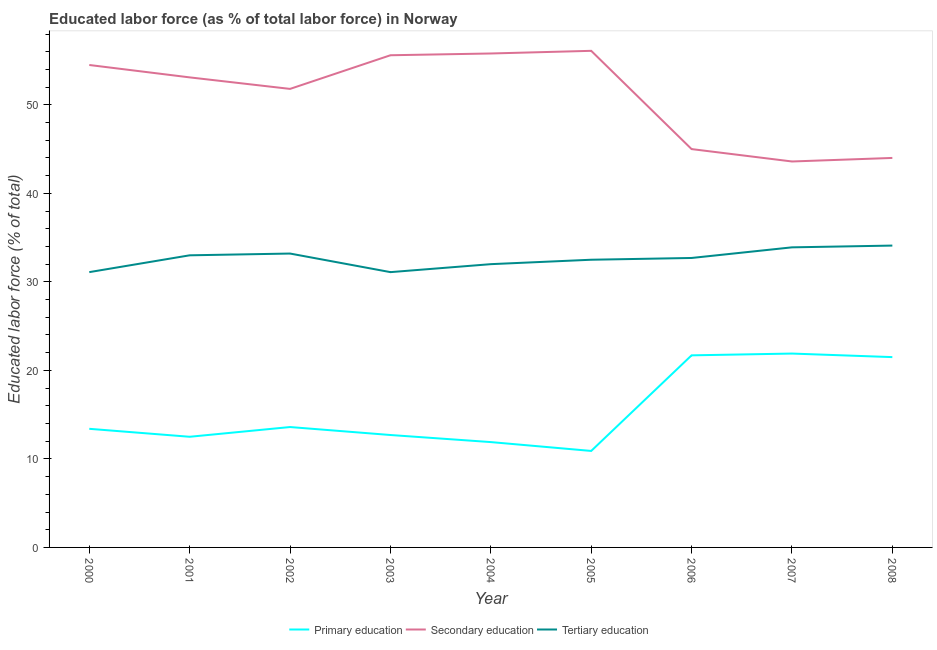Does the line corresponding to percentage of labor force who received tertiary education intersect with the line corresponding to percentage of labor force who received primary education?
Your answer should be compact. No. Is the number of lines equal to the number of legend labels?
Offer a terse response. Yes. What is the percentage of labor force who received tertiary education in 2006?
Your answer should be very brief. 32.7. Across all years, what is the maximum percentage of labor force who received tertiary education?
Offer a very short reply. 34.1. Across all years, what is the minimum percentage of labor force who received tertiary education?
Give a very brief answer. 31.1. What is the total percentage of labor force who received primary education in the graph?
Provide a short and direct response. 140.1. What is the difference between the percentage of labor force who received primary education in 2007 and the percentage of labor force who received secondary education in 2005?
Your answer should be compact. -34.2. What is the average percentage of labor force who received secondary education per year?
Offer a terse response. 51.06. In the year 2005, what is the difference between the percentage of labor force who received secondary education and percentage of labor force who received primary education?
Ensure brevity in your answer.  45.2. In how many years, is the percentage of labor force who received secondary education greater than 12 %?
Keep it short and to the point. 9. What is the ratio of the percentage of labor force who received secondary education in 2002 to that in 2007?
Your answer should be compact. 1.19. Is the percentage of labor force who received secondary education in 2000 less than that in 2004?
Ensure brevity in your answer.  Yes. Is the difference between the percentage of labor force who received tertiary education in 2003 and 2007 greater than the difference between the percentage of labor force who received secondary education in 2003 and 2007?
Give a very brief answer. No. What is the difference between the highest and the second highest percentage of labor force who received tertiary education?
Offer a terse response. 0.2. What is the difference between the highest and the lowest percentage of labor force who received secondary education?
Your answer should be very brief. 12.5. In how many years, is the percentage of labor force who received tertiary education greater than the average percentage of labor force who received tertiary education taken over all years?
Ensure brevity in your answer.  5. Is the sum of the percentage of labor force who received tertiary education in 2002 and 2003 greater than the maximum percentage of labor force who received primary education across all years?
Offer a terse response. Yes. Is it the case that in every year, the sum of the percentage of labor force who received primary education and percentage of labor force who received secondary education is greater than the percentage of labor force who received tertiary education?
Keep it short and to the point. Yes. Is the percentage of labor force who received tertiary education strictly greater than the percentage of labor force who received secondary education over the years?
Provide a succinct answer. No. Is the percentage of labor force who received secondary education strictly less than the percentage of labor force who received primary education over the years?
Provide a short and direct response. No. How many lines are there?
Ensure brevity in your answer.  3. What is the difference between two consecutive major ticks on the Y-axis?
Your answer should be compact. 10. Are the values on the major ticks of Y-axis written in scientific E-notation?
Offer a very short reply. No. Does the graph contain any zero values?
Keep it short and to the point. No. Where does the legend appear in the graph?
Keep it short and to the point. Bottom center. What is the title of the graph?
Make the answer very short. Educated labor force (as % of total labor force) in Norway. Does "Domestic" appear as one of the legend labels in the graph?
Offer a very short reply. No. What is the label or title of the Y-axis?
Keep it short and to the point. Educated labor force (% of total). What is the Educated labor force (% of total) of Primary education in 2000?
Offer a terse response. 13.4. What is the Educated labor force (% of total) of Secondary education in 2000?
Your answer should be very brief. 54.5. What is the Educated labor force (% of total) of Tertiary education in 2000?
Make the answer very short. 31.1. What is the Educated labor force (% of total) in Primary education in 2001?
Your response must be concise. 12.5. What is the Educated labor force (% of total) in Secondary education in 2001?
Your answer should be very brief. 53.1. What is the Educated labor force (% of total) in Tertiary education in 2001?
Offer a terse response. 33. What is the Educated labor force (% of total) of Primary education in 2002?
Your answer should be very brief. 13.6. What is the Educated labor force (% of total) of Secondary education in 2002?
Give a very brief answer. 51.8. What is the Educated labor force (% of total) of Tertiary education in 2002?
Your response must be concise. 33.2. What is the Educated labor force (% of total) of Primary education in 2003?
Keep it short and to the point. 12.7. What is the Educated labor force (% of total) of Secondary education in 2003?
Ensure brevity in your answer.  55.6. What is the Educated labor force (% of total) of Tertiary education in 2003?
Make the answer very short. 31.1. What is the Educated labor force (% of total) in Primary education in 2004?
Give a very brief answer. 11.9. What is the Educated labor force (% of total) in Secondary education in 2004?
Give a very brief answer. 55.8. What is the Educated labor force (% of total) in Primary education in 2005?
Give a very brief answer. 10.9. What is the Educated labor force (% of total) in Secondary education in 2005?
Ensure brevity in your answer.  56.1. What is the Educated labor force (% of total) of Tertiary education in 2005?
Keep it short and to the point. 32.5. What is the Educated labor force (% of total) in Primary education in 2006?
Your response must be concise. 21.7. What is the Educated labor force (% of total) in Tertiary education in 2006?
Ensure brevity in your answer.  32.7. What is the Educated labor force (% of total) in Primary education in 2007?
Ensure brevity in your answer.  21.9. What is the Educated labor force (% of total) of Secondary education in 2007?
Your answer should be compact. 43.6. What is the Educated labor force (% of total) in Tertiary education in 2007?
Your answer should be very brief. 33.9. What is the Educated labor force (% of total) in Secondary education in 2008?
Offer a terse response. 44. What is the Educated labor force (% of total) in Tertiary education in 2008?
Keep it short and to the point. 34.1. Across all years, what is the maximum Educated labor force (% of total) in Primary education?
Offer a terse response. 21.9. Across all years, what is the maximum Educated labor force (% of total) in Secondary education?
Offer a very short reply. 56.1. Across all years, what is the maximum Educated labor force (% of total) of Tertiary education?
Your response must be concise. 34.1. Across all years, what is the minimum Educated labor force (% of total) of Primary education?
Keep it short and to the point. 10.9. Across all years, what is the minimum Educated labor force (% of total) of Secondary education?
Provide a succinct answer. 43.6. Across all years, what is the minimum Educated labor force (% of total) of Tertiary education?
Your answer should be very brief. 31.1. What is the total Educated labor force (% of total) in Primary education in the graph?
Your answer should be very brief. 140.1. What is the total Educated labor force (% of total) in Secondary education in the graph?
Offer a terse response. 459.5. What is the total Educated labor force (% of total) in Tertiary education in the graph?
Offer a terse response. 293.6. What is the difference between the Educated labor force (% of total) in Primary education in 2000 and that in 2001?
Provide a succinct answer. 0.9. What is the difference between the Educated labor force (% of total) of Tertiary education in 2000 and that in 2001?
Your response must be concise. -1.9. What is the difference between the Educated labor force (% of total) of Secondary education in 2000 and that in 2002?
Provide a succinct answer. 2.7. What is the difference between the Educated labor force (% of total) of Tertiary education in 2000 and that in 2002?
Your response must be concise. -2.1. What is the difference between the Educated labor force (% of total) in Secondary education in 2000 and that in 2003?
Provide a short and direct response. -1.1. What is the difference between the Educated labor force (% of total) in Tertiary education in 2000 and that in 2003?
Your response must be concise. 0. What is the difference between the Educated labor force (% of total) of Primary education in 2000 and that in 2005?
Provide a short and direct response. 2.5. What is the difference between the Educated labor force (% of total) of Secondary education in 2000 and that in 2005?
Offer a terse response. -1.6. What is the difference between the Educated labor force (% of total) of Secondary education in 2000 and that in 2006?
Ensure brevity in your answer.  9.5. What is the difference between the Educated labor force (% of total) in Tertiary education in 2000 and that in 2006?
Provide a succinct answer. -1.6. What is the difference between the Educated labor force (% of total) of Secondary education in 2000 and that in 2008?
Make the answer very short. 10.5. What is the difference between the Educated labor force (% of total) of Tertiary education in 2000 and that in 2008?
Offer a very short reply. -3. What is the difference between the Educated labor force (% of total) in Secondary education in 2001 and that in 2002?
Ensure brevity in your answer.  1.3. What is the difference between the Educated labor force (% of total) of Tertiary education in 2001 and that in 2003?
Your answer should be compact. 1.9. What is the difference between the Educated labor force (% of total) of Primary education in 2001 and that in 2004?
Provide a short and direct response. 0.6. What is the difference between the Educated labor force (% of total) of Tertiary education in 2001 and that in 2004?
Give a very brief answer. 1. What is the difference between the Educated labor force (% of total) in Primary education in 2001 and that in 2005?
Your response must be concise. 1.6. What is the difference between the Educated labor force (% of total) of Secondary education in 2001 and that in 2005?
Provide a succinct answer. -3. What is the difference between the Educated labor force (% of total) of Tertiary education in 2001 and that in 2005?
Offer a terse response. 0.5. What is the difference between the Educated labor force (% of total) in Primary education in 2001 and that in 2006?
Your response must be concise. -9.2. What is the difference between the Educated labor force (% of total) of Secondary education in 2001 and that in 2007?
Offer a very short reply. 9.5. What is the difference between the Educated labor force (% of total) in Tertiary education in 2001 and that in 2008?
Your answer should be very brief. -1.1. What is the difference between the Educated labor force (% of total) of Primary education in 2002 and that in 2003?
Keep it short and to the point. 0.9. What is the difference between the Educated labor force (% of total) of Secondary education in 2002 and that in 2003?
Provide a short and direct response. -3.8. What is the difference between the Educated labor force (% of total) of Tertiary education in 2002 and that in 2003?
Ensure brevity in your answer.  2.1. What is the difference between the Educated labor force (% of total) in Primary education in 2002 and that in 2004?
Your answer should be compact. 1.7. What is the difference between the Educated labor force (% of total) of Tertiary education in 2002 and that in 2004?
Your response must be concise. 1.2. What is the difference between the Educated labor force (% of total) of Primary education in 2002 and that in 2005?
Give a very brief answer. 2.7. What is the difference between the Educated labor force (% of total) of Secondary education in 2002 and that in 2005?
Your answer should be very brief. -4.3. What is the difference between the Educated labor force (% of total) of Tertiary education in 2002 and that in 2005?
Your response must be concise. 0.7. What is the difference between the Educated labor force (% of total) of Primary education in 2002 and that in 2007?
Your answer should be very brief. -8.3. What is the difference between the Educated labor force (% of total) in Secondary education in 2002 and that in 2007?
Ensure brevity in your answer.  8.2. What is the difference between the Educated labor force (% of total) of Tertiary education in 2002 and that in 2007?
Give a very brief answer. -0.7. What is the difference between the Educated labor force (% of total) in Primary education in 2002 and that in 2008?
Your response must be concise. -7.9. What is the difference between the Educated labor force (% of total) in Secondary education in 2002 and that in 2008?
Offer a very short reply. 7.8. What is the difference between the Educated labor force (% of total) in Tertiary education in 2002 and that in 2008?
Give a very brief answer. -0.9. What is the difference between the Educated labor force (% of total) in Primary education in 2003 and that in 2004?
Give a very brief answer. 0.8. What is the difference between the Educated labor force (% of total) of Tertiary education in 2003 and that in 2004?
Offer a terse response. -0.9. What is the difference between the Educated labor force (% of total) of Primary education in 2003 and that in 2005?
Provide a succinct answer. 1.8. What is the difference between the Educated labor force (% of total) of Tertiary education in 2003 and that in 2005?
Your answer should be compact. -1.4. What is the difference between the Educated labor force (% of total) of Tertiary education in 2003 and that in 2006?
Keep it short and to the point. -1.6. What is the difference between the Educated labor force (% of total) in Primary education in 2003 and that in 2007?
Keep it short and to the point. -9.2. What is the difference between the Educated labor force (% of total) in Secondary education in 2003 and that in 2007?
Make the answer very short. 12. What is the difference between the Educated labor force (% of total) of Primary education in 2003 and that in 2008?
Ensure brevity in your answer.  -8.8. What is the difference between the Educated labor force (% of total) of Secondary education in 2003 and that in 2008?
Your answer should be compact. 11.6. What is the difference between the Educated labor force (% of total) of Secondary education in 2004 and that in 2005?
Your answer should be compact. -0.3. What is the difference between the Educated labor force (% of total) of Secondary education in 2004 and that in 2006?
Keep it short and to the point. 10.8. What is the difference between the Educated labor force (% of total) of Primary education in 2004 and that in 2007?
Provide a succinct answer. -10. What is the difference between the Educated labor force (% of total) in Tertiary education in 2005 and that in 2006?
Your response must be concise. -0.2. What is the difference between the Educated labor force (% of total) of Secondary education in 2005 and that in 2007?
Your response must be concise. 12.5. What is the difference between the Educated labor force (% of total) in Tertiary education in 2005 and that in 2008?
Your answer should be very brief. -1.6. What is the difference between the Educated labor force (% of total) in Primary education in 2006 and that in 2007?
Your answer should be very brief. -0.2. What is the difference between the Educated labor force (% of total) of Tertiary education in 2006 and that in 2007?
Your answer should be very brief. -1.2. What is the difference between the Educated labor force (% of total) in Primary education in 2007 and that in 2008?
Offer a terse response. 0.4. What is the difference between the Educated labor force (% of total) in Secondary education in 2007 and that in 2008?
Your response must be concise. -0.4. What is the difference between the Educated labor force (% of total) in Primary education in 2000 and the Educated labor force (% of total) in Secondary education in 2001?
Offer a very short reply. -39.7. What is the difference between the Educated labor force (% of total) in Primary education in 2000 and the Educated labor force (% of total) in Tertiary education in 2001?
Your answer should be compact. -19.6. What is the difference between the Educated labor force (% of total) of Secondary education in 2000 and the Educated labor force (% of total) of Tertiary education in 2001?
Provide a succinct answer. 21.5. What is the difference between the Educated labor force (% of total) in Primary education in 2000 and the Educated labor force (% of total) in Secondary education in 2002?
Make the answer very short. -38.4. What is the difference between the Educated labor force (% of total) in Primary education in 2000 and the Educated labor force (% of total) in Tertiary education in 2002?
Offer a very short reply. -19.8. What is the difference between the Educated labor force (% of total) of Secondary education in 2000 and the Educated labor force (% of total) of Tertiary education in 2002?
Provide a succinct answer. 21.3. What is the difference between the Educated labor force (% of total) of Primary education in 2000 and the Educated labor force (% of total) of Secondary education in 2003?
Your answer should be compact. -42.2. What is the difference between the Educated labor force (% of total) in Primary education in 2000 and the Educated labor force (% of total) in Tertiary education in 2003?
Ensure brevity in your answer.  -17.7. What is the difference between the Educated labor force (% of total) of Secondary education in 2000 and the Educated labor force (% of total) of Tertiary education in 2003?
Offer a terse response. 23.4. What is the difference between the Educated labor force (% of total) of Primary education in 2000 and the Educated labor force (% of total) of Secondary education in 2004?
Provide a short and direct response. -42.4. What is the difference between the Educated labor force (% of total) of Primary education in 2000 and the Educated labor force (% of total) of Tertiary education in 2004?
Ensure brevity in your answer.  -18.6. What is the difference between the Educated labor force (% of total) in Primary education in 2000 and the Educated labor force (% of total) in Secondary education in 2005?
Give a very brief answer. -42.7. What is the difference between the Educated labor force (% of total) of Primary education in 2000 and the Educated labor force (% of total) of Tertiary education in 2005?
Ensure brevity in your answer.  -19.1. What is the difference between the Educated labor force (% of total) in Primary education in 2000 and the Educated labor force (% of total) in Secondary education in 2006?
Offer a very short reply. -31.6. What is the difference between the Educated labor force (% of total) of Primary education in 2000 and the Educated labor force (% of total) of Tertiary education in 2006?
Your response must be concise. -19.3. What is the difference between the Educated labor force (% of total) in Secondary education in 2000 and the Educated labor force (% of total) in Tertiary education in 2006?
Ensure brevity in your answer.  21.8. What is the difference between the Educated labor force (% of total) in Primary education in 2000 and the Educated labor force (% of total) in Secondary education in 2007?
Offer a terse response. -30.2. What is the difference between the Educated labor force (% of total) in Primary education in 2000 and the Educated labor force (% of total) in Tertiary education in 2007?
Make the answer very short. -20.5. What is the difference between the Educated labor force (% of total) in Secondary education in 2000 and the Educated labor force (% of total) in Tertiary education in 2007?
Your response must be concise. 20.6. What is the difference between the Educated labor force (% of total) of Primary education in 2000 and the Educated labor force (% of total) of Secondary education in 2008?
Make the answer very short. -30.6. What is the difference between the Educated labor force (% of total) in Primary education in 2000 and the Educated labor force (% of total) in Tertiary education in 2008?
Offer a very short reply. -20.7. What is the difference between the Educated labor force (% of total) of Secondary education in 2000 and the Educated labor force (% of total) of Tertiary education in 2008?
Your answer should be compact. 20.4. What is the difference between the Educated labor force (% of total) in Primary education in 2001 and the Educated labor force (% of total) in Secondary education in 2002?
Your answer should be compact. -39.3. What is the difference between the Educated labor force (% of total) of Primary education in 2001 and the Educated labor force (% of total) of Tertiary education in 2002?
Keep it short and to the point. -20.7. What is the difference between the Educated labor force (% of total) of Secondary education in 2001 and the Educated labor force (% of total) of Tertiary education in 2002?
Your response must be concise. 19.9. What is the difference between the Educated labor force (% of total) of Primary education in 2001 and the Educated labor force (% of total) of Secondary education in 2003?
Provide a short and direct response. -43.1. What is the difference between the Educated labor force (% of total) in Primary education in 2001 and the Educated labor force (% of total) in Tertiary education in 2003?
Your answer should be very brief. -18.6. What is the difference between the Educated labor force (% of total) of Secondary education in 2001 and the Educated labor force (% of total) of Tertiary education in 2003?
Offer a very short reply. 22. What is the difference between the Educated labor force (% of total) of Primary education in 2001 and the Educated labor force (% of total) of Secondary education in 2004?
Your answer should be very brief. -43.3. What is the difference between the Educated labor force (% of total) in Primary education in 2001 and the Educated labor force (% of total) in Tertiary education in 2004?
Your answer should be compact. -19.5. What is the difference between the Educated labor force (% of total) of Secondary education in 2001 and the Educated labor force (% of total) of Tertiary education in 2004?
Give a very brief answer. 21.1. What is the difference between the Educated labor force (% of total) of Primary education in 2001 and the Educated labor force (% of total) of Secondary education in 2005?
Your answer should be very brief. -43.6. What is the difference between the Educated labor force (% of total) of Secondary education in 2001 and the Educated labor force (% of total) of Tertiary education in 2005?
Keep it short and to the point. 20.6. What is the difference between the Educated labor force (% of total) in Primary education in 2001 and the Educated labor force (% of total) in Secondary education in 2006?
Offer a terse response. -32.5. What is the difference between the Educated labor force (% of total) in Primary education in 2001 and the Educated labor force (% of total) in Tertiary education in 2006?
Your answer should be very brief. -20.2. What is the difference between the Educated labor force (% of total) in Secondary education in 2001 and the Educated labor force (% of total) in Tertiary education in 2006?
Provide a succinct answer. 20.4. What is the difference between the Educated labor force (% of total) in Primary education in 2001 and the Educated labor force (% of total) in Secondary education in 2007?
Provide a short and direct response. -31.1. What is the difference between the Educated labor force (% of total) of Primary education in 2001 and the Educated labor force (% of total) of Tertiary education in 2007?
Provide a succinct answer. -21.4. What is the difference between the Educated labor force (% of total) of Primary education in 2001 and the Educated labor force (% of total) of Secondary education in 2008?
Provide a short and direct response. -31.5. What is the difference between the Educated labor force (% of total) in Primary education in 2001 and the Educated labor force (% of total) in Tertiary education in 2008?
Your answer should be compact. -21.6. What is the difference between the Educated labor force (% of total) in Primary education in 2002 and the Educated labor force (% of total) in Secondary education in 2003?
Keep it short and to the point. -42. What is the difference between the Educated labor force (% of total) of Primary education in 2002 and the Educated labor force (% of total) of Tertiary education in 2003?
Provide a short and direct response. -17.5. What is the difference between the Educated labor force (% of total) of Secondary education in 2002 and the Educated labor force (% of total) of Tertiary education in 2003?
Give a very brief answer. 20.7. What is the difference between the Educated labor force (% of total) in Primary education in 2002 and the Educated labor force (% of total) in Secondary education in 2004?
Ensure brevity in your answer.  -42.2. What is the difference between the Educated labor force (% of total) in Primary education in 2002 and the Educated labor force (% of total) in Tertiary education in 2004?
Your response must be concise. -18.4. What is the difference between the Educated labor force (% of total) of Secondary education in 2002 and the Educated labor force (% of total) of Tertiary education in 2004?
Give a very brief answer. 19.8. What is the difference between the Educated labor force (% of total) in Primary education in 2002 and the Educated labor force (% of total) in Secondary education in 2005?
Provide a succinct answer. -42.5. What is the difference between the Educated labor force (% of total) of Primary education in 2002 and the Educated labor force (% of total) of Tertiary education in 2005?
Keep it short and to the point. -18.9. What is the difference between the Educated labor force (% of total) in Secondary education in 2002 and the Educated labor force (% of total) in Tertiary education in 2005?
Keep it short and to the point. 19.3. What is the difference between the Educated labor force (% of total) in Primary education in 2002 and the Educated labor force (% of total) in Secondary education in 2006?
Ensure brevity in your answer.  -31.4. What is the difference between the Educated labor force (% of total) of Primary education in 2002 and the Educated labor force (% of total) of Tertiary education in 2006?
Give a very brief answer. -19.1. What is the difference between the Educated labor force (% of total) in Primary education in 2002 and the Educated labor force (% of total) in Secondary education in 2007?
Your answer should be very brief. -30. What is the difference between the Educated labor force (% of total) in Primary education in 2002 and the Educated labor force (% of total) in Tertiary education in 2007?
Your response must be concise. -20.3. What is the difference between the Educated labor force (% of total) of Secondary education in 2002 and the Educated labor force (% of total) of Tertiary education in 2007?
Your response must be concise. 17.9. What is the difference between the Educated labor force (% of total) in Primary education in 2002 and the Educated labor force (% of total) in Secondary education in 2008?
Keep it short and to the point. -30.4. What is the difference between the Educated labor force (% of total) of Primary education in 2002 and the Educated labor force (% of total) of Tertiary education in 2008?
Your response must be concise. -20.5. What is the difference between the Educated labor force (% of total) in Secondary education in 2002 and the Educated labor force (% of total) in Tertiary education in 2008?
Your response must be concise. 17.7. What is the difference between the Educated labor force (% of total) of Primary education in 2003 and the Educated labor force (% of total) of Secondary education in 2004?
Your answer should be very brief. -43.1. What is the difference between the Educated labor force (% of total) of Primary education in 2003 and the Educated labor force (% of total) of Tertiary education in 2004?
Your response must be concise. -19.3. What is the difference between the Educated labor force (% of total) of Secondary education in 2003 and the Educated labor force (% of total) of Tertiary education in 2004?
Provide a succinct answer. 23.6. What is the difference between the Educated labor force (% of total) in Primary education in 2003 and the Educated labor force (% of total) in Secondary education in 2005?
Keep it short and to the point. -43.4. What is the difference between the Educated labor force (% of total) of Primary education in 2003 and the Educated labor force (% of total) of Tertiary education in 2005?
Offer a terse response. -19.8. What is the difference between the Educated labor force (% of total) in Secondary education in 2003 and the Educated labor force (% of total) in Tertiary education in 2005?
Keep it short and to the point. 23.1. What is the difference between the Educated labor force (% of total) of Primary education in 2003 and the Educated labor force (% of total) of Secondary education in 2006?
Provide a short and direct response. -32.3. What is the difference between the Educated labor force (% of total) of Secondary education in 2003 and the Educated labor force (% of total) of Tertiary education in 2006?
Offer a terse response. 22.9. What is the difference between the Educated labor force (% of total) of Primary education in 2003 and the Educated labor force (% of total) of Secondary education in 2007?
Your answer should be compact. -30.9. What is the difference between the Educated labor force (% of total) in Primary education in 2003 and the Educated labor force (% of total) in Tertiary education in 2007?
Provide a short and direct response. -21.2. What is the difference between the Educated labor force (% of total) in Secondary education in 2003 and the Educated labor force (% of total) in Tertiary education in 2007?
Your response must be concise. 21.7. What is the difference between the Educated labor force (% of total) of Primary education in 2003 and the Educated labor force (% of total) of Secondary education in 2008?
Provide a short and direct response. -31.3. What is the difference between the Educated labor force (% of total) of Primary education in 2003 and the Educated labor force (% of total) of Tertiary education in 2008?
Your answer should be very brief. -21.4. What is the difference between the Educated labor force (% of total) of Secondary education in 2003 and the Educated labor force (% of total) of Tertiary education in 2008?
Provide a succinct answer. 21.5. What is the difference between the Educated labor force (% of total) in Primary education in 2004 and the Educated labor force (% of total) in Secondary education in 2005?
Your response must be concise. -44.2. What is the difference between the Educated labor force (% of total) in Primary education in 2004 and the Educated labor force (% of total) in Tertiary education in 2005?
Offer a terse response. -20.6. What is the difference between the Educated labor force (% of total) in Secondary education in 2004 and the Educated labor force (% of total) in Tertiary education in 2005?
Your answer should be very brief. 23.3. What is the difference between the Educated labor force (% of total) in Primary education in 2004 and the Educated labor force (% of total) in Secondary education in 2006?
Offer a very short reply. -33.1. What is the difference between the Educated labor force (% of total) in Primary education in 2004 and the Educated labor force (% of total) in Tertiary education in 2006?
Keep it short and to the point. -20.8. What is the difference between the Educated labor force (% of total) in Secondary education in 2004 and the Educated labor force (% of total) in Tertiary education in 2006?
Provide a succinct answer. 23.1. What is the difference between the Educated labor force (% of total) of Primary education in 2004 and the Educated labor force (% of total) of Secondary education in 2007?
Keep it short and to the point. -31.7. What is the difference between the Educated labor force (% of total) of Primary education in 2004 and the Educated labor force (% of total) of Tertiary education in 2007?
Your answer should be very brief. -22. What is the difference between the Educated labor force (% of total) in Secondary education in 2004 and the Educated labor force (% of total) in Tertiary education in 2007?
Offer a terse response. 21.9. What is the difference between the Educated labor force (% of total) of Primary education in 2004 and the Educated labor force (% of total) of Secondary education in 2008?
Give a very brief answer. -32.1. What is the difference between the Educated labor force (% of total) in Primary education in 2004 and the Educated labor force (% of total) in Tertiary education in 2008?
Offer a very short reply. -22.2. What is the difference between the Educated labor force (% of total) in Secondary education in 2004 and the Educated labor force (% of total) in Tertiary education in 2008?
Give a very brief answer. 21.7. What is the difference between the Educated labor force (% of total) of Primary education in 2005 and the Educated labor force (% of total) of Secondary education in 2006?
Offer a terse response. -34.1. What is the difference between the Educated labor force (% of total) in Primary education in 2005 and the Educated labor force (% of total) in Tertiary education in 2006?
Offer a terse response. -21.8. What is the difference between the Educated labor force (% of total) in Secondary education in 2005 and the Educated labor force (% of total) in Tertiary education in 2006?
Your answer should be very brief. 23.4. What is the difference between the Educated labor force (% of total) of Primary education in 2005 and the Educated labor force (% of total) of Secondary education in 2007?
Your response must be concise. -32.7. What is the difference between the Educated labor force (% of total) of Primary education in 2005 and the Educated labor force (% of total) of Tertiary education in 2007?
Offer a terse response. -23. What is the difference between the Educated labor force (% of total) of Secondary education in 2005 and the Educated labor force (% of total) of Tertiary education in 2007?
Provide a succinct answer. 22.2. What is the difference between the Educated labor force (% of total) of Primary education in 2005 and the Educated labor force (% of total) of Secondary education in 2008?
Provide a short and direct response. -33.1. What is the difference between the Educated labor force (% of total) in Primary education in 2005 and the Educated labor force (% of total) in Tertiary education in 2008?
Provide a succinct answer. -23.2. What is the difference between the Educated labor force (% of total) of Secondary education in 2005 and the Educated labor force (% of total) of Tertiary education in 2008?
Offer a very short reply. 22. What is the difference between the Educated labor force (% of total) of Primary education in 2006 and the Educated labor force (% of total) of Secondary education in 2007?
Offer a very short reply. -21.9. What is the difference between the Educated labor force (% of total) in Primary education in 2006 and the Educated labor force (% of total) in Tertiary education in 2007?
Give a very brief answer. -12.2. What is the difference between the Educated labor force (% of total) of Primary education in 2006 and the Educated labor force (% of total) of Secondary education in 2008?
Ensure brevity in your answer.  -22.3. What is the difference between the Educated labor force (% of total) in Primary education in 2007 and the Educated labor force (% of total) in Secondary education in 2008?
Offer a terse response. -22.1. What is the difference between the Educated labor force (% of total) in Primary education in 2007 and the Educated labor force (% of total) in Tertiary education in 2008?
Provide a succinct answer. -12.2. What is the difference between the Educated labor force (% of total) in Secondary education in 2007 and the Educated labor force (% of total) in Tertiary education in 2008?
Offer a very short reply. 9.5. What is the average Educated labor force (% of total) of Primary education per year?
Keep it short and to the point. 15.57. What is the average Educated labor force (% of total) in Secondary education per year?
Your response must be concise. 51.06. What is the average Educated labor force (% of total) in Tertiary education per year?
Keep it short and to the point. 32.62. In the year 2000, what is the difference between the Educated labor force (% of total) of Primary education and Educated labor force (% of total) of Secondary education?
Provide a succinct answer. -41.1. In the year 2000, what is the difference between the Educated labor force (% of total) of Primary education and Educated labor force (% of total) of Tertiary education?
Give a very brief answer. -17.7. In the year 2000, what is the difference between the Educated labor force (% of total) in Secondary education and Educated labor force (% of total) in Tertiary education?
Provide a succinct answer. 23.4. In the year 2001, what is the difference between the Educated labor force (% of total) of Primary education and Educated labor force (% of total) of Secondary education?
Offer a very short reply. -40.6. In the year 2001, what is the difference between the Educated labor force (% of total) in Primary education and Educated labor force (% of total) in Tertiary education?
Offer a terse response. -20.5. In the year 2001, what is the difference between the Educated labor force (% of total) in Secondary education and Educated labor force (% of total) in Tertiary education?
Offer a very short reply. 20.1. In the year 2002, what is the difference between the Educated labor force (% of total) of Primary education and Educated labor force (% of total) of Secondary education?
Your answer should be very brief. -38.2. In the year 2002, what is the difference between the Educated labor force (% of total) in Primary education and Educated labor force (% of total) in Tertiary education?
Offer a very short reply. -19.6. In the year 2002, what is the difference between the Educated labor force (% of total) of Secondary education and Educated labor force (% of total) of Tertiary education?
Make the answer very short. 18.6. In the year 2003, what is the difference between the Educated labor force (% of total) of Primary education and Educated labor force (% of total) of Secondary education?
Keep it short and to the point. -42.9. In the year 2003, what is the difference between the Educated labor force (% of total) in Primary education and Educated labor force (% of total) in Tertiary education?
Provide a succinct answer. -18.4. In the year 2003, what is the difference between the Educated labor force (% of total) in Secondary education and Educated labor force (% of total) in Tertiary education?
Your answer should be very brief. 24.5. In the year 2004, what is the difference between the Educated labor force (% of total) of Primary education and Educated labor force (% of total) of Secondary education?
Your response must be concise. -43.9. In the year 2004, what is the difference between the Educated labor force (% of total) of Primary education and Educated labor force (% of total) of Tertiary education?
Your response must be concise. -20.1. In the year 2004, what is the difference between the Educated labor force (% of total) in Secondary education and Educated labor force (% of total) in Tertiary education?
Keep it short and to the point. 23.8. In the year 2005, what is the difference between the Educated labor force (% of total) in Primary education and Educated labor force (% of total) in Secondary education?
Keep it short and to the point. -45.2. In the year 2005, what is the difference between the Educated labor force (% of total) of Primary education and Educated labor force (% of total) of Tertiary education?
Make the answer very short. -21.6. In the year 2005, what is the difference between the Educated labor force (% of total) of Secondary education and Educated labor force (% of total) of Tertiary education?
Offer a very short reply. 23.6. In the year 2006, what is the difference between the Educated labor force (% of total) of Primary education and Educated labor force (% of total) of Secondary education?
Ensure brevity in your answer.  -23.3. In the year 2006, what is the difference between the Educated labor force (% of total) of Secondary education and Educated labor force (% of total) of Tertiary education?
Give a very brief answer. 12.3. In the year 2007, what is the difference between the Educated labor force (% of total) of Primary education and Educated labor force (% of total) of Secondary education?
Provide a succinct answer. -21.7. In the year 2007, what is the difference between the Educated labor force (% of total) of Primary education and Educated labor force (% of total) of Tertiary education?
Make the answer very short. -12. In the year 2007, what is the difference between the Educated labor force (% of total) in Secondary education and Educated labor force (% of total) in Tertiary education?
Give a very brief answer. 9.7. In the year 2008, what is the difference between the Educated labor force (% of total) of Primary education and Educated labor force (% of total) of Secondary education?
Your answer should be compact. -22.5. In the year 2008, what is the difference between the Educated labor force (% of total) of Primary education and Educated labor force (% of total) of Tertiary education?
Provide a short and direct response. -12.6. What is the ratio of the Educated labor force (% of total) of Primary education in 2000 to that in 2001?
Give a very brief answer. 1.07. What is the ratio of the Educated labor force (% of total) in Secondary education in 2000 to that in 2001?
Provide a short and direct response. 1.03. What is the ratio of the Educated labor force (% of total) of Tertiary education in 2000 to that in 2001?
Provide a succinct answer. 0.94. What is the ratio of the Educated labor force (% of total) in Primary education in 2000 to that in 2002?
Ensure brevity in your answer.  0.99. What is the ratio of the Educated labor force (% of total) in Secondary education in 2000 to that in 2002?
Give a very brief answer. 1.05. What is the ratio of the Educated labor force (% of total) in Tertiary education in 2000 to that in 2002?
Offer a very short reply. 0.94. What is the ratio of the Educated labor force (% of total) of Primary education in 2000 to that in 2003?
Your answer should be compact. 1.06. What is the ratio of the Educated labor force (% of total) of Secondary education in 2000 to that in 2003?
Keep it short and to the point. 0.98. What is the ratio of the Educated labor force (% of total) in Primary education in 2000 to that in 2004?
Your answer should be compact. 1.13. What is the ratio of the Educated labor force (% of total) in Secondary education in 2000 to that in 2004?
Ensure brevity in your answer.  0.98. What is the ratio of the Educated labor force (% of total) in Tertiary education in 2000 to that in 2004?
Offer a very short reply. 0.97. What is the ratio of the Educated labor force (% of total) in Primary education in 2000 to that in 2005?
Provide a short and direct response. 1.23. What is the ratio of the Educated labor force (% of total) of Secondary education in 2000 to that in 2005?
Give a very brief answer. 0.97. What is the ratio of the Educated labor force (% of total) in Tertiary education in 2000 to that in 2005?
Provide a succinct answer. 0.96. What is the ratio of the Educated labor force (% of total) of Primary education in 2000 to that in 2006?
Provide a succinct answer. 0.62. What is the ratio of the Educated labor force (% of total) of Secondary education in 2000 to that in 2006?
Your answer should be compact. 1.21. What is the ratio of the Educated labor force (% of total) in Tertiary education in 2000 to that in 2006?
Provide a succinct answer. 0.95. What is the ratio of the Educated labor force (% of total) in Primary education in 2000 to that in 2007?
Offer a terse response. 0.61. What is the ratio of the Educated labor force (% of total) in Secondary education in 2000 to that in 2007?
Your answer should be compact. 1.25. What is the ratio of the Educated labor force (% of total) in Tertiary education in 2000 to that in 2007?
Provide a succinct answer. 0.92. What is the ratio of the Educated labor force (% of total) in Primary education in 2000 to that in 2008?
Your response must be concise. 0.62. What is the ratio of the Educated labor force (% of total) in Secondary education in 2000 to that in 2008?
Your response must be concise. 1.24. What is the ratio of the Educated labor force (% of total) of Tertiary education in 2000 to that in 2008?
Your answer should be compact. 0.91. What is the ratio of the Educated labor force (% of total) in Primary education in 2001 to that in 2002?
Provide a succinct answer. 0.92. What is the ratio of the Educated labor force (% of total) of Secondary education in 2001 to that in 2002?
Offer a very short reply. 1.03. What is the ratio of the Educated labor force (% of total) in Tertiary education in 2001 to that in 2002?
Provide a short and direct response. 0.99. What is the ratio of the Educated labor force (% of total) in Primary education in 2001 to that in 2003?
Provide a succinct answer. 0.98. What is the ratio of the Educated labor force (% of total) in Secondary education in 2001 to that in 2003?
Offer a very short reply. 0.95. What is the ratio of the Educated labor force (% of total) in Tertiary education in 2001 to that in 2003?
Provide a succinct answer. 1.06. What is the ratio of the Educated labor force (% of total) of Primary education in 2001 to that in 2004?
Make the answer very short. 1.05. What is the ratio of the Educated labor force (% of total) in Secondary education in 2001 to that in 2004?
Keep it short and to the point. 0.95. What is the ratio of the Educated labor force (% of total) in Tertiary education in 2001 to that in 2004?
Provide a short and direct response. 1.03. What is the ratio of the Educated labor force (% of total) of Primary education in 2001 to that in 2005?
Your answer should be very brief. 1.15. What is the ratio of the Educated labor force (% of total) in Secondary education in 2001 to that in 2005?
Offer a very short reply. 0.95. What is the ratio of the Educated labor force (% of total) of Tertiary education in 2001 to that in 2005?
Provide a succinct answer. 1.02. What is the ratio of the Educated labor force (% of total) in Primary education in 2001 to that in 2006?
Your answer should be compact. 0.58. What is the ratio of the Educated labor force (% of total) of Secondary education in 2001 to that in 2006?
Keep it short and to the point. 1.18. What is the ratio of the Educated labor force (% of total) of Tertiary education in 2001 to that in 2006?
Provide a short and direct response. 1.01. What is the ratio of the Educated labor force (% of total) in Primary education in 2001 to that in 2007?
Keep it short and to the point. 0.57. What is the ratio of the Educated labor force (% of total) of Secondary education in 2001 to that in 2007?
Offer a terse response. 1.22. What is the ratio of the Educated labor force (% of total) of Tertiary education in 2001 to that in 2007?
Your response must be concise. 0.97. What is the ratio of the Educated labor force (% of total) of Primary education in 2001 to that in 2008?
Your answer should be compact. 0.58. What is the ratio of the Educated labor force (% of total) in Secondary education in 2001 to that in 2008?
Make the answer very short. 1.21. What is the ratio of the Educated labor force (% of total) in Tertiary education in 2001 to that in 2008?
Keep it short and to the point. 0.97. What is the ratio of the Educated labor force (% of total) of Primary education in 2002 to that in 2003?
Your answer should be compact. 1.07. What is the ratio of the Educated labor force (% of total) in Secondary education in 2002 to that in 2003?
Provide a short and direct response. 0.93. What is the ratio of the Educated labor force (% of total) in Tertiary education in 2002 to that in 2003?
Your answer should be very brief. 1.07. What is the ratio of the Educated labor force (% of total) of Primary education in 2002 to that in 2004?
Provide a short and direct response. 1.14. What is the ratio of the Educated labor force (% of total) of Secondary education in 2002 to that in 2004?
Your answer should be very brief. 0.93. What is the ratio of the Educated labor force (% of total) of Tertiary education in 2002 to that in 2004?
Your answer should be compact. 1.04. What is the ratio of the Educated labor force (% of total) of Primary education in 2002 to that in 2005?
Offer a very short reply. 1.25. What is the ratio of the Educated labor force (% of total) of Secondary education in 2002 to that in 2005?
Give a very brief answer. 0.92. What is the ratio of the Educated labor force (% of total) of Tertiary education in 2002 to that in 2005?
Ensure brevity in your answer.  1.02. What is the ratio of the Educated labor force (% of total) of Primary education in 2002 to that in 2006?
Make the answer very short. 0.63. What is the ratio of the Educated labor force (% of total) of Secondary education in 2002 to that in 2006?
Keep it short and to the point. 1.15. What is the ratio of the Educated labor force (% of total) in Tertiary education in 2002 to that in 2006?
Your response must be concise. 1.02. What is the ratio of the Educated labor force (% of total) in Primary education in 2002 to that in 2007?
Offer a very short reply. 0.62. What is the ratio of the Educated labor force (% of total) of Secondary education in 2002 to that in 2007?
Give a very brief answer. 1.19. What is the ratio of the Educated labor force (% of total) of Tertiary education in 2002 to that in 2007?
Give a very brief answer. 0.98. What is the ratio of the Educated labor force (% of total) in Primary education in 2002 to that in 2008?
Ensure brevity in your answer.  0.63. What is the ratio of the Educated labor force (% of total) of Secondary education in 2002 to that in 2008?
Your answer should be compact. 1.18. What is the ratio of the Educated labor force (% of total) of Tertiary education in 2002 to that in 2008?
Ensure brevity in your answer.  0.97. What is the ratio of the Educated labor force (% of total) of Primary education in 2003 to that in 2004?
Provide a short and direct response. 1.07. What is the ratio of the Educated labor force (% of total) in Tertiary education in 2003 to that in 2004?
Give a very brief answer. 0.97. What is the ratio of the Educated labor force (% of total) in Primary education in 2003 to that in 2005?
Keep it short and to the point. 1.17. What is the ratio of the Educated labor force (% of total) of Tertiary education in 2003 to that in 2005?
Your answer should be very brief. 0.96. What is the ratio of the Educated labor force (% of total) of Primary education in 2003 to that in 2006?
Offer a very short reply. 0.59. What is the ratio of the Educated labor force (% of total) of Secondary education in 2003 to that in 2006?
Your answer should be compact. 1.24. What is the ratio of the Educated labor force (% of total) of Tertiary education in 2003 to that in 2006?
Keep it short and to the point. 0.95. What is the ratio of the Educated labor force (% of total) in Primary education in 2003 to that in 2007?
Your response must be concise. 0.58. What is the ratio of the Educated labor force (% of total) of Secondary education in 2003 to that in 2007?
Keep it short and to the point. 1.28. What is the ratio of the Educated labor force (% of total) in Tertiary education in 2003 to that in 2007?
Your answer should be compact. 0.92. What is the ratio of the Educated labor force (% of total) in Primary education in 2003 to that in 2008?
Provide a short and direct response. 0.59. What is the ratio of the Educated labor force (% of total) of Secondary education in 2003 to that in 2008?
Offer a very short reply. 1.26. What is the ratio of the Educated labor force (% of total) in Tertiary education in 2003 to that in 2008?
Provide a succinct answer. 0.91. What is the ratio of the Educated labor force (% of total) of Primary education in 2004 to that in 2005?
Offer a very short reply. 1.09. What is the ratio of the Educated labor force (% of total) of Secondary education in 2004 to that in 2005?
Ensure brevity in your answer.  0.99. What is the ratio of the Educated labor force (% of total) in Tertiary education in 2004 to that in 2005?
Make the answer very short. 0.98. What is the ratio of the Educated labor force (% of total) of Primary education in 2004 to that in 2006?
Give a very brief answer. 0.55. What is the ratio of the Educated labor force (% of total) in Secondary education in 2004 to that in 2006?
Make the answer very short. 1.24. What is the ratio of the Educated labor force (% of total) of Tertiary education in 2004 to that in 2006?
Provide a succinct answer. 0.98. What is the ratio of the Educated labor force (% of total) of Primary education in 2004 to that in 2007?
Your answer should be very brief. 0.54. What is the ratio of the Educated labor force (% of total) in Secondary education in 2004 to that in 2007?
Give a very brief answer. 1.28. What is the ratio of the Educated labor force (% of total) of Tertiary education in 2004 to that in 2007?
Offer a very short reply. 0.94. What is the ratio of the Educated labor force (% of total) of Primary education in 2004 to that in 2008?
Your response must be concise. 0.55. What is the ratio of the Educated labor force (% of total) of Secondary education in 2004 to that in 2008?
Provide a short and direct response. 1.27. What is the ratio of the Educated labor force (% of total) in Tertiary education in 2004 to that in 2008?
Your answer should be compact. 0.94. What is the ratio of the Educated labor force (% of total) in Primary education in 2005 to that in 2006?
Give a very brief answer. 0.5. What is the ratio of the Educated labor force (% of total) of Secondary education in 2005 to that in 2006?
Your answer should be very brief. 1.25. What is the ratio of the Educated labor force (% of total) of Tertiary education in 2005 to that in 2006?
Provide a succinct answer. 0.99. What is the ratio of the Educated labor force (% of total) in Primary education in 2005 to that in 2007?
Give a very brief answer. 0.5. What is the ratio of the Educated labor force (% of total) of Secondary education in 2005 to that in 2007?
Offer a terse response. 1.29. What is the ratio of the Educated labor force (% of total) of Tertiary education in 2005 to that in 2007?
Provide a short and direct response. 0.96. What is the ratio of the Educated labor force (% of total) of Primary education in 2005 to that in 2008?
Offer a very short reply. 0.51. What is the ratio of the Educated labor force (% of total) of Secondary education in 2005 to that in 2008?
Provide a short and direct response. 1.27. What is the ratio of the Educated labor force (% of total) in Tertiary education in 2005 to that in 2008?
Ensure brevity in your answer.  0.95. What is the ratio of the Educated labor force (% of total) of Primary education in 2006 to that in 2007?
Your response must be concise. 0.99. What is the ratio of the Educated labor force (% of total) in Secondary education in 2006 to that in 2007?
Offer a terse response. 1.03. What is the ratio of the Educated labor force (% of total) of Tertiary education in 2006 to that in 2007?
Your answer should be very brief. 0.96. What is the ratio of the Educated labor force (% of total) of Primary education in 2006 to that in 2008?
Offer a very short reply. 1.01. What is the ratio of the Educated labor force (% of total) of Secondary education in 2006 to that in 2008?
Provide a short and direct response. 1.02. What is the ratio of the Educated labor force (% of total) in Tertiary education in 2006 to that in 2008?
Provide a short and direct response. 0.96. What is the ratio of the Educated labor force (% of total) of Primary education in 2007 to that in 2008?
Keep it short and to the point. 1.02. What is the ratio of the Educated labor force (% of total) of Secondary education in 2007 to that in 2008?
Ensure brevity in your answer.  0.99. What is the difference between the highest and the lowest Educated labor force (% of total) of Primary education?
Provide a short and direct response. 11. What is the difference between the highest and the lowest Educated labor force (% of total) in Tertiary education?
Ensure brevity in your answer.  3. 